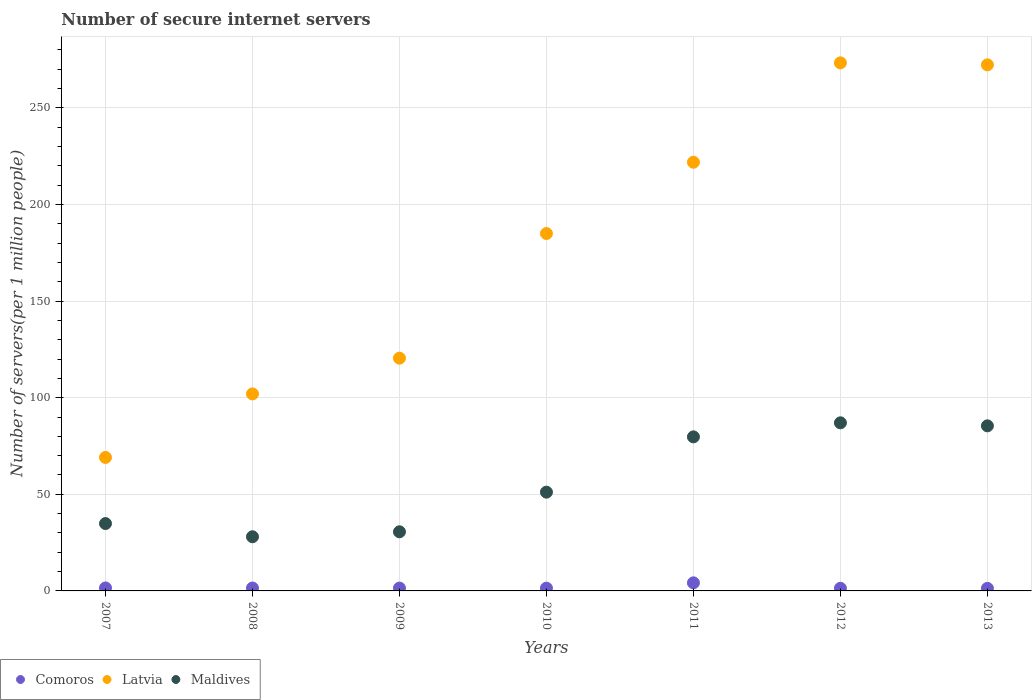What is the number of secure internet servers in Latvia in 2012?
Provide a short and direct response. 273.31. Across all years, what is the maximum number of secure internet servers in Comoros?
Your response must be concise. 4.19. Across all years, what is the minimum number of secure internet servers in Comoros?
Keep it short and to the point. 1.33. In which year was the number of secure internet servers in Latvia maximum?
Offer a terse response. 2012. In which year was the number of secure internet servers in Latvia minimum?
Your response must be concise. 2007. What is the total number of secure internet servers in Comoros in the graph?
Your response must be concise. 12.82. What is the difference between the number of secure internet servers in Maldives in 2007 and that in 2013?
Keep it short and to the point. -50.58. What is the difference between the number of secure internet servers in Comoros in 2011 and the number of secure internet servers in Maldives in 2007?
Make the answer very short. -30.67. What is the average number of secure internet servers in Comoros per year?
Ensure brevity in your answer.  1.83. In the year 2008, what is the difference between the number of secure internet servers in Latvia and number of secure internet servers in Comoros?
Provide a short and direct response. 100.46. In how many years, is the number of secure internet servers in Maldives greater than 270?
Your answer should be very brief. 0. What is the ratio of the number of secure internet servers in Latvia in 2007 to that in 2012?
Ensure brevity in your answer.  0.25. Is the number of secure internet servers in Maldives in 2009 less than that in 2012?
Offer a very short reply. Yes. What is the difference between the highest and the second highest number of secure internet servers in Comoros?
Offer a very short reply. 2.65. What is the difference between the highest and the lowest number of secure internet servers in Latvia?
Make the answer very short. 204.23. In how many years, is the number of secure internet servers in Comoros greater than the average number of secure internet servers in Comoros taken over all years?
Make the answer very short. 1. Is the number of secure internet servers in Maldives strictly greater than the number of secure internet servers in Latvia over the years?
Your answer should be compact. No. Is the number of secure internet servers in Comoros strictly less than the number of secure internet servers in Maldives over the years?
Offer a very short reply. Yes. How many dotlines are there?
Keep it short and to the point. 3. Are the values on the major ticks of Y-axis written in scientific E-notation?
Make the answer very short. No. Does the graph contain any zero values?
Provide a succinct answer. No. Does the graph contain grids?
Keep it short and to the point. Yes. Where does the legend appear in the graph?
Your answer should be very brief. Bottom left. How are the legend labels stacked?
Give a very brief answer. Horizontal. What is the title of the graph?
Your response must be concise. Number of secure internet servers. What is the label or title of the Y-axis?
Make the answer very short. Number of servers(per 1 million people). What is the Number of servers(per 1 million people) of Comoros in 2007?
Keep it short and to the point. 1.54. What is the Number of servers(per 1 million people) in Latvia in 2007?
Provide a short and direct response. 69.08. What is the Number of servers(per 1 million people) in Maldives in 2007?
Make the answer very short. 34.86. What is the Number of servers(per 1 million people) of Comoros in 2008?
Make the answer very short. 1.5. What is the Number of servers(per 1 million people) in Latvia in 2008?
Ensure brevity in your answer.  101.96. What is the Number of servers(per 1 million people) in Maldives in 2008?
Give a very brief answer. 28.04. What is the Number of servers(per 1 million people) of Comoros in 2009?
Ensure brevity in your answer.  1.47. What is the Number of servers(per 1 million people) of Latvia in 2009?
Provide a succinct answer. 120.47. What is the Number of servers(per 1 million people) of Maldives in 2009?
Keep it short and to the point. 30.61. What is the Number of servers(per 1 million people) in Comoros in 2010?
Keep it short and to the point. 1.43. What is the Number of servers(per 1 million people) of Latvia in 2010?
Offer a terse response. 184.98. What is the Number of servers(per 1 million people) of Maldives in 2010?
Provide a succinct answer. 51.12. What is the Number of servers(per 1 million people) in Comoros in 2011?
Provide a short and direct response. 4.19. What is the Number of servers(per 1 million people) in Latvia in 2011?
Ensure brevity in your answer.  221.88. What is the Number of servers(per 1 million people) in Maldives in 2011?
Keep it short and to the point. 79.74. What is the Number of servers(per 1 million people) of Comoros in 2012?
Make the answer very short. 1.36. What is the Number of servers(per 1 million people) in Latvia in 2012?
Offer a terse response. 273.31. What is the Number of servers(per 1 million people) in Maldives in 2012?
Provide a short and direct response. 87. What is the Number of servers(per 1 million people) of Comoros in 2013?
Your answer should be very brief. 1.33. What is the Number of servers(per 1 million people) of Latvia in 2013?
Your response must be concise. 272.28. What is the Number of servers(per 1 million people) in Maldives in 2013?
Provide a short and direct response. 85.44. Across all years, what is the maximum Number of servers(per 1 million people) in Comoros?
Provide a short and direct response. 4.19. Across all years, what is the maximum Number of servers(per 1 million people) of Latvia?
Provide a succinct answer. 273.31. Across all years, what is the maximum Number of servers(per 1 million people) in Maldives?
Provide a succinct answer. 87. Across all years, what is the minimum Number of servers(per 1 million people) in Comoros?
Keep it short and to the point. 1.33. Across all years, what is the minimum Number of servers(per 1 million people) of Latvia?
Provide a short and direct response. 69.08. Across all years, what is the minimum Number of servers(per 1 million people) of Maldives?
Your answer should be very brief. 28.04. What is the total Number of servers(per 1 million people) in Comoros in the graph?
Provide a succinct answer. 12.82. What is the total Number of servers(per 1 million people) of Latvia in the graph?
Ensure brevity in your answer.  1243.95. What is the total Number of servers(per 1 million people) in Maldives in the graph?
Make the answer very short. 396.8. What is the difference between the Number of servers(per 1 million people) in Comoros in 2007 and that in 2008?
Your answer should be very brief. 0.04. What is the difference between the Number of servers(per 1 million people) in Latvia in 2007 and that in 2008?
Provide a succinct answer. -32.88. What is the difference between the Number of servers(per 1 million people) of Maldives in 2007 and that in 2008?
Your response must be concise. 6.83. What is the difference between the Number of servers(per 1 million people) in Comoros in 2007 and that in 2009?
Offer a very short reply. 0.07. What is the difference between the Number of servers(per 1 million people) of Latvia in 2007 and that in 2009?
Provide a short and direct response. -51.39. What is the difference between the Number of servers(per 1 million people) of Maldives in 2007 and that in 2009?
Your response must be concise. 4.26. What is the difference between the Number of servers(per 1 million people) in Comoros in 2007 and that in 2010?
Offer a very short reply. 0.11. What is the difference between the Number of servers(per 1 million people) in Latvia in 2007 and that in 2010?
Ensure brevity in your answer.  -115.9. What is the difference between the Number of servers(per 1 million people) of Maldives in 2007 and that in 2010?
Provide a short and direct response. -16.25. What is the difference between the Number of servers(per 1 million people) in Comoros in 2007 and that in 2011?
Offer a very short reply. -2.65. What is the difference between the Number of servers(per 1 million people) in Latvia in 2007 and that in 2011?
Your answer should be very brief. -152.8. What is the difference between the Number of servers(per 1 million people) of Maldives in 2007 and that in 2011?
Provide a succinct answer. -44.87. What is the difference between the Number of servers(per 1 million people) of Comoros in 2007 and that in 2012?
Offer a very short reply. 0.18. What is the difference between the Number of servers(per 1 million people) of Latvia in 2007 and that in 2012?
Make the answer very short. -204.23. What is the difference between the Number of servers(per 1 million people) in Maldives in 2007 and that in 2012?
Keep it short and to the point. -52.14. What is the difference between the Number of servers(per 1 million people) in Comoros in 2007 and that in 2013?
Give a very brief answer. 0.21. What is the difference between the Number of servers(per 1 million people) of Latvia in 2007 and that in 2013?
Make the answer very short. -203.2. What is the difference between the Number of servers(per 1 million people) of Maldives in 2007 and that in 2013?
Give a very brief answer. -50.58. What is the difference between the Number of servers(per 1 million people) in Comoros in 2008 and that in 2009?
Provide a short and direct response. 0.04. What is the difference between the Number of servers(per 1 million people) of Latvia in 2008 and that in 2009?
Provide a succinct answer. -18.51. What is the difference between the Number of servers(per 1 million people) of Maldives in 2008 and that in 2009?
Your answer should be compact. -2.57. What is the difference between the Number of servers(per 1 million people) in Comoros in 2008 and that in 2010?
Your response must be concise. 0.07. What is the difference between the Number of servers(per 1 million people) of Latvia in 2008 and that in 2010?
Provide a succinct answer. -83.02. What is the difference between the Number of servers(per 1 million people) of Maldives in 2008 and that in 2010?
Provide a succinct answer. -23.08. What is the difference between the Number of servers(per 1 million people) in Comoros in 2008 and that in 2011?
Provide a short and direct response. -2.69. What is the difference between the Number of servers(per 1 million people) of Latvia in 2008 and that in 2011?
Offer a terse response. -119.92. What is the difference between the Number of servers(per 1 million people) of Maldives in 2008 and that in 2011?
Your answer should be compact. -51.7. What is the difference between the Number of servers(per 1 million people) of Comoros in 2008 and that in 2012?
Provide a succinct answer. 0.14. What is the difference between the Number of servers(per 1 million people) of Latvia in 2008 and that in 2012?
Offer a terse response. -171.35. What is the difference between the Number of servers(per 1 million people) of Maldives in 2008 and that in 2012?
Your answer should be very brief. -58.97. What is the difference between the Number of servers(per 1 million people) in Comoros in 2008 and that in 2013?
Keep it short and to the point. 0.17. What is the difference between the Number of servers(per 1 million people) of Latvia in 2008 and that in 2013?
Keep it short and to the point. -170.32. What is the difference between the Number of servers(per 1 million people) in Maldives in 2008 and that in 2013?
Give a very brief answer. -57.41. What is the difference between the Number of servers(per 1 million people) of Comoros in 2009 and that in 2010?
Your response must be concise. 0.04. What is the difference between the Number of servers(per 1 million people) of Latvia in 2009 and that in 2010?
Your answer should be very brief. -64.51. What is the difference between the Number of servers(per 1 million people) in Maldives in 2009 and that in 2010?
Offer a very short reply. -20.51. What is the difference between the Number of servers(per 1 million people) of Comoros in 2009 and that in 2011?
Keep it short and to the point. -2.72. What is the difference between the Number of servers(per 1 million people) in Latvia in 2009 and that in 2011?
Offer a very short reply. -101.41. What is the difference between the Number of servers(per 1 million people) in Maldives in 2009 and that in 2011?
Offer a very short reply. -49.13. What is the difference between the Number of servers(per 1 million people) of Comoros in 2009 and that in 2012?
Offer a very short reply. 0.1. What is the difference between the Number of servers(per 1 million people) of Latvia in 2009 and that in 2012?
Make the answer very short. -152.84. What is the difference between the Number of servers(per 1 million people) in Maldives in 2009 and that in 2012?
Ensure brevity in your answer.  -56.39. What is the difference between the Number of servers(per 1 million people) of Comoros in 2009 and that in 2013?
Your answer should be very brief. 0.14. What is the difference between the Number of servers(per 1 million people) of Latvia in 2009 and that in 2013?
Give a very brief answer. -151.81. What is the difference between the Number of servers(per 1 million people) of Maldives in 2009 and that in 2013?
Ensure brevity in your answer.  -54.84. What is the difference between the Number of servers(per 1 million people) of Comoros in 2010 and that in 2011?
Offer a terse response. -2.76. What is the difference between the Number of servers(per 1 million people) in Latvia in 2010 and that in 2011?
Give a very brief answer. -36.9. What is the difference between the Number of servers(per 1 million people) in Maldives in 2010 and that in 2011?
Your answer should be very brief. -28.62. What is the difference between the Number of servers(per 1 million people) of Comoros in 2010 and that in 2012?
Make the answer very short. 0.07. What is the difference between the Number of servers(per 1 million people) of Latvia in 2010 and that in 2012?
Offer a terse response. -88.33. What is the difference between the Number of servers(per 1 million people) of Maldives in 2010 and that in 2012?
Keep it short and to the point. -35.89. What is the difference between the Number of servers(per 1 million people) of Comoros in 2010 and that in 2013?
Make the answer very short. 0.1. What is the difference between the Number of servers(per 1 million people) in Latvia in 2010 and that in 2013?
Your answer should be compact. -87.3. What is the difference between the Number of servers(per 1 million people) of Maldives in 2010 and that in 2013?
Offer a terse response. -34.33. What is the difference between the Number of servers(per 1 million people) of Comoros in 2011 and that in 2012?
Offer a very short reply. 2.83. What is the difference between the Number of servers(per 1 million people) in Latvia in 2011 and that in 2012?
Offer a very short reply. -51.43. What is the difference between the Number of servers(per 1 million people) of Maldives in 2011 and that in 2012?
Provide a succinct answer. -7.27. What is the difference between the Number of servers(per 1 million people) of Comoros in 2011 and that in 2013?
Keep it short and to the point. 2.86. What is the difference between the Number of servers(per 1 million people) of Latvia in 2011 and that in 2013?
Give a very brief answer. -50.4. What is the difference between the Number of servers(per 1 million people) in Maldives in 2011 and that in 2013?
Make the answer very short. -5.71. What is the difference between the Number of servers(per 1 million people) of Comoros in 2012 and that in 2013?
Offer a terse response. 0.03. What is the difference between the Number of servers(per 1 million people) in Latvia in 2012 and that in 2013?
Provide a succinct answer. 1.03. What is the difference between the Number of servers(per 1 million people) in Maldives in 2012 and that in 2013?
Provide a succinct answer. 1.56. What is the difference between the Number of servers(per 1 million people) in Comoros in 2007 and the Number of servers(per 1 million people) in Latvia in 2008?
Make the answer very short. -100.42. What is the difference between the Number of servers(per 1 million people) in Comoros in 2007 and the Number of servers(per 1 million people) in Maldives in 2008?
Your response must be concise. -26.5. What is the difference between the Number of servers(per 1 million people) of Latvia in 2007 and the Number of servers(per 1 million people) of Maldives in 2008?
Offer a terse response. 41.05. What is the difference between the Number of servers(per 1 million people) of Comoros in 2007 and the Number of servers(per 1 million people) of Latvia in 2009?
Offer a very short reply. -118.93. What is the difference between the Number of servers(per 1 million people) in Comoros in 2007 and the Number of servers(per 1 million people) in Maldives in 2009?
Your answer should be very brief. -29.07. What is the difference between the Number of servers(per 1 million people) in Latvia in 2007 and the Number of servers(per 1 million people) in Maldives in 2009?
Provide a succinct answer. 38.47. What is the difference between the Number of servers(per 1 million people) in Comoros in 2007 and the Number of servers(per 1 million people) in Latvia in 2010?
Your answer should be compact. -183.44. What is the difference between the Number of servers(per 1 million people) of Comoros in 2007 and the Number of servers(per 1 million people) of Maldives in 2010?
Your answer should be very brief. -49.58. What is the difference between the Number of servers(per 1 million people) in Latvia in 2007 and the Number of servers(per 1 million people) in Maldives in 2010?
Provide a short and direct response. 17.96. What is the difference between the Number of servers(per 1 million people) of Comoros in 2007 and the Number of servers(per 1 million people) of Latvia in 2011?
Your answer should be very brief. -220.34. What is the difference between the Number of servers(per 1 million people) of Comoros in 2007 and the Number of servers(per 1 million people) of Maldives in 2011?
Offer a terse response. -78.2. What is the difference between the Number of servers(per 1 million people) in Latvia in 2007 and the Number of servers(per 1 million people) in Maldives in 2011?
Your response must be concise. -10.66. What is the difference between the Number of servers(per 1 million people) of Comoros in 2007 and the Number of servers(per 1 million people) of Latvia in 2012?
Provide a short and direct response. -271.77. What is the difference between the Number of servers(per 1 million people) in Comoros in 2007 and the Number of servers(per 1 million people) in Maldives in 2012?
Keep it short and to the point. -85.46. What is the difference between the Number of servers(per 1 million people) of Latvia in 2007 and the Number of servers(per 1 million people) of Maldives in 2012?
Your answer should be compact. -17.92. What is the difference between the Number of servers(per 1 million people) in Comoros in 2007 and the Number of servers(per 1 million people) in Latvia in 2013?
Offer a very short reply. -270.74. What is the difference between the Number of servers(per 1 million people) of Comoros in 2007 and the Number of servers(per 1 million people) of Maldives in 2013?
Your response must be concise. -83.9. What is the difference between the Number of servers(per 1 million people) of Latvia in 2007 and the Number of servers(per 1 million people) of Maldives in 2013?
Give a very brief answer. -16.36. What is the difference between the Number of servers(per 1 million people) of Comoros in 2008 and the Number of servers(per 1 million people) of Latvia in 2009?
Provide a succinct answer. -118.96. What is the difference between the Number of servers(per 1 million people) of Comoros in 2008 and the Number of servers(per 1 million people) of Maldives in 2009?
Your response must be concise. -29.11. What is the difference between the Number of servers(per 1 million people) of Latvia in 2008 and the Number of servers(per 1 million people) of Maldives in 2009?
Provide a short and direct response. 71.35. What is the difference between the Number of servers(per 1 million people) of Comoros in 2008 and the Number of servers(per 1 million people) of Latvia in 2010?
Give a very brief answer. -183.47. What is the difference between the Number of servers(per 1 million people) in Comoros in 2008 and the Number of servers(per 1 million people) in Maldives in 2010?
Keep it short and to the point. -49.61. What is the difference between the Number of servers(per 1 million people) of Latvia in 2008 and the Number of servers(per 1 million people) of Maldives in 2010?
Make the answer very short. 50.84. What is the difference between the Number of servers(per 1 million people) in Comoros in 2008 and the Number of servers(per 1 million people) in Latvia in 2011?
Provide a succinct answer. -220.37. What is the difference between the Number of servers(per 1 million people) in Comoros in 2008 and the Number of servers(per 1 million people) in Maldives in 2011?
Your answer should be compact. -78.23. What is the difference between the Number of servers(per 1 million people) of Latvia in 2008 and the Number of servers(per 1 million people) of Maldives in 2011?
Your answer should be very brief. 22.22. What is the difference between the Number of servers(per 1 million people) in Comoros in 2008 and the Number of servers(per 1 million people) in Latvia in 2012?
Give a very brief answer. -271.81. What is the difference between the Number of servers(per 1 million people) of Comoros in 2008 and the Number of servers(per 1 million people) of Maldives in 2012?
Your answer should be compact. -85.5. What is the difference between the Number of servers(per 1 million people) in Latvia in 2008 and the Number of servers(per 1 million people) in Maldives in 2012?
Make the answer very short. 14.96. What is the difference between the Number of servers(per 1 million people) in Comoros in 2008 and the Number of servers(per 1 million people) in Latvia in 2013?
Provide a short and direct response. -270.78. What is the difference between the Number of servers(per 1 million people) in Comoros in 2008 and the Number of servers(per 1 million people) in Maldives in 2013?
Keep it short and to the point. -83.94. What is the difference between the Number of servers(per 1 million people) of Latvia in 2008 and the Number of servers(per 1 million people) of Maldives in 2013?
Give a very brief answer. 16.52. What is the difference between the Number of servers(per 1 million people) of Comoros in 2009 and the Number of servers(per 1 million people) of Latvia in 2010?
Offer a terse response. -183.51. What is the difference between the Number of servers(per 1 million people) in Comoros in 2009 and the Number of servers(per 1 million people) in Maldives in 2010?
Your answer should be compact. -49.65. What is the difference between the Number of servers(per 1 million people) in Latvia in 2009 and the Number of servers(per 1 million people) in Maldives in 2010?
Offer a very short reply. 69.35. What is the difference between the Number of servers(per 1 million people) in Comoros in 2009 and the Number of servers(per 1 million people) in Latvia in 2011?
Offer a very short reply. -220.41. What is the difference between the Number of servers(per 1 million people) of Comoros in 2009 and the Number of servers(per 1 million people) of Maldives in 2011?
Provide a succinct answer. -78.27. What is the difference between the Number of servers(per 1 million people) in Latvia in 2009 and the Number of servers(per 1 million people) in Maldives in 2011?
Ensure brevity in your answer.  40.73. What is the difference between the Number of servers(per 1 million people) in Comoros in 2009 and the Number of servers(per 1 million people) in Latvia in 2012?
Your answer should be compact. -271.84. What is the difference between the Number of servers(per 1 million people) of Comoros in 2009 and the Number of servers(per 1 million people) of Maldives in 2012?
Keep it short and to the point. -85.54. What is the difference between the Number of servers(per 1 million people) in Latvia in 2009 and the Number of servers(per 1 million people) in Maldives in 2012?
Offer a terse response. 33.46. What is the difference between the Number of servers(per 1 million people) of Comoros in 2009 and the Number of servers(per 1 million people) of Latvia in 2013?
Offer a very short reply. -270.81. What is the difference between the Number of servers(per 1 million people) of Comoros in 2009 and the Number of servers(per 1 million people) of Maldives in 2013?
Your answer should be very brief. -83.98. What is the difference between the Number of servers(per 1 million people) of Latvia in 2009 and the Number of servers(per 1 million people) of Maldives in 2013?
Your response must be concise. 35.02. What is the difference between the Number of servers(per 1 million people) in Comoros in 2010 and the Number of servers(per 1 million people) in Latvia in 2011?
Offer a terse response. -220.44. What is the difference between the Number of servers(per 1 million people) in Comoros in 2010 and the Number of servers(per 1 million people) in Maldives in 2011?
Keep it short and to the point. -78.3. What is the difference between the Number of servers(per 1 million people) in Latvia in 2010 and the Number of servers(per 1 million people) in Maldives in 2011?
Make the answer very short. 105.24. What is the difference between the Number of servers(per 1 million people) in Comoros in 2010 and the Number of servers(per 1 million people) in Latvia in 2012?
Offer a terse response. -271.88. What is the difference between the Number of servers(per 1 million people) of Comoros in 2010 and the Number of servers(per 1 million people) of Maldives in 2012?
Offer a very short reply. -85.57. What is the difference between the Number of servers(per 1 million people) in Latvia in 2010 and the Number of servers(per 1 million people) in Maldives in 2012?
Make the answer very short. 97.97. What is the difference between the Number of servers(per 1 million people) of Comoros in 2010 and the Number of servers(per 1 million people) of Latvia in 2013?
Your answer should be very brief. -270.85. What is the difference between the Number of servers(per 1 million people) in Comoros in 2010 and the Number of servers(per 1 million people) in Maldives in 2013?
Your answer should be compact. -84.01. What is the difference between the Number of servers(per 1 million people) of Latvia in 2010 and the Number of servers(per 1 million people) of Maldives in 2013?
Your answer should be compact. 99.53. What is the difference between the Number of servers(per 1 million people) of Comoros in 2011 and the Number of servers(per 1 million people) of Latvia in 2012?
Your answer should be very brief. -269.12. What is the difference between the Number of servers(per 1 million people) in Comoros in 2011 and the Number of servers(per 1 million people) in Maldives in 2012?
Your answer should be very brief. -82.81. What is the difference between the Number of servers(per 1 million people) of Latvia in 2011 and the Number of servers(per 1 million people) of Maldives in 2012?
Ensure brevity in your answer.  134.87. What is the difference between the Number of servers(per 1 million people) of Comoros in 2011 and the Number of servers(per 1 million people) of Latvia in 2013?
Your response must be concise. -268.09. What is the difference between the Number of servers(per 1 million people) of Comoros in 2011 and the Number of servers(per 1 million people) of Maldives in 2013?
Make the answer very short. -81.25. What is the difference between the Number of servers(per 1 million people) of Latvia in 2011 and the Number of servers(per 1 million people) of Maldives in 2013?
Make the answer very short. 136.43. What is the difference between the Number of servers(per 1 million people) of Comoros in 2012 and the Number of servers(per 1 million people) of Latvia in 2013?
Give a very brief answer. -270.92. What is the difference between the Number of servers(per 1 million people) of Comoros in 2012 and the Number of servers(per 1 million people) of Maldives in 2013?
Make the answer very short. -84.08. What is the difference between the Number of servers(per 1 million people) in Latvia in 2012 and the Number of servers(per 1 million people) in Maldives in 2013?
Provide a short and direct response. 187.87. What is the average Number of servers(per 1 million people) of Comoros per year?
Make the answer very short. 1.83. What is the average Number of servers(per 1 million people) in Latvia per year?
Give a very brief answer. 177.71. What is the average Number of servers(per 1 million people) in Maldives per year?
Ensure brevity in your answer.  56.69. In the year 2007, what is the difference between the Number of servers(per 1 million people) in Comoros and Number of servers(per 1 million people) in Latvia?
Provide a succinct answer. -67.54. In the year 2007, what is the difference between the Number of servers(per 1 million people) of Comoros and Number of servers(per 1 million people) of Maldives?
Offer a very short reply. -33.32. In the year 2007, what is the difference between the Number of servers(per 1 million people) of Latvia and Number of servers(per 1 million people) of Maldives?
Your answer should be very brief. 34.22. In the year 2008, what is the difference between the Number of servers(per 1 million people) in Comoros and Number of servers(per 1 million people) in Latvia?
Provide a succinct answer. -100.46. In the year 2008, what is the difference between the Number of servers(per 1 million people) of Comoros and Number of servers(per 1 million people) of Maldives?
Ensure brevity in your answer.  -26.53. In the year 2008, what is the difference between the Number of servers(per 1 million people) in Latvia and Number of servers(per 1 million people) in Maldives?
Give a very brief answer. 73.92. In the year 2009, what is the difference between the Number of servers(per 1 million people) in Comoros and Number of servers(per 1 million people) in Latvia?
Your response must be concise. -119. In the year 2009, what is the difference between the Number of servers(per 1 million people) of Comoros and Number of servers(per 1 million people) of Maldives?
Give a very brief answer. -29.14. In the year 2009, what is the difference between the Number of servers(per 1 million people) of Latvia and Number of servers(per 1 million people) of Maldives?
Provide a short and direct response. 89.86. In the year 2010, what is the difference between the Number of servers(per 1 million people) of Comoros and Number of servers(per 1 million people) of Latvia?
Make the answer very short. -183.55. In the year 2010, what is the difference between the Number of servers(per 1 million people) in Comoros and Number of servers(per 1 million people) in Maldives?
Give a very brief answer. -49.69. In the year 2010, what is the difference between the Number of servers(per 1 million people) in Latvia and Number of servers(per 1 million people) in Maldives?
Make the answer very short. 133.86. In the year 2011, what is the difference between the Number of servers(per 1 million people) of Comoros and Number of servers(per 1 million people) of Latvia?
Your answer should be very brief. -217.69. In the year 2011, what is the difference between the Number of servers(per 1 million people) of Comoros and Number of servers(per 1 million people) of Maldives?
Provide a succinct answer. -75.55. In the year 2011, what is the difference between the Number of servers(per 1 million people) of Latvia and Number of servers(per 1 million people) of Maldives?
Your response must be concise. 142.14. In the year 2012, what is the difference between the Number of servers(per 1 million people) of Comoros and Number of servers(per 1 million people) of Latvia?
Keep it short and to the point. -271.95. In the year 2012, what is the difference between the Number of servers(per 1 million people) in Comoros and Number of servers(per 1 million people) in Maldives?
Provide a succinct answer. -85.64. In the year 2012, what is the difference between the Number of servers(per 1 million people) in Latvia and Number of servers(per 1 million people) in Maldives?
Keep it short and to the point. 186.31. In the year 2013, what is the difference between the Number of servers(per 1 million people) of Comoros and Number of servers(per 1 million people) of Latvia?
Your response must be concise. -270.95. In the year 2013, what is the difference between the Number of servers(per 1 million people) in Comoros and Number of servers(per 1 million people) in Maldives?
Your answer should be very brief. -84.11. In the year 2013, what is the difference between the Number of servers(per 1 million people) in Latvia and Number of servers(per 1 million people) in Maldives?
Offer a terse response. 186.84. What is the ratio of the Number of servers(per 1 million people) in Comoros in 2007 to that in 2008?
Offer a very short reply. 1.02. What is the ratio of the Number of servers(per 1 million people) in Latvia in 2007 to that in 2008?
Give a very brief answer. 0.68. What is the ratio of the Number of servers(per 1 million people) of Maldives in 2007 to that in 2008?
Keep it short and to the point. 1.24. What is the ratio of the Number of servers(per 1 million people) in Comoros in 2007 to that in 2009?
Provide a succinct answer. 1.05. What is the ratio of the Number of servers(per 1 million people) in Latvia in 2007 to that in 2009?
Your answer should be very brief. 0.57. What is the ratio of the Number of servers(per 1 million people) of Maldives in 2007 to that in 2009?
Provide a short and direct response. 1.14. What is the ratio of the Number of servers(per 1 million people) of Comoros in 2007 to that in 2010?
Your answer should be very brief. 1.08. What is the ratio of the Number of servers(per 1 million people) of Latvia in 2007 to that in 2010?
Make the answer very short. 0.37. What is the ratio of the Number of servers(per 1 million people) in Maldives in 2007 to that in 2010?
Provide a short and direct response. 0.68. What is the ratio of the Number of servers(per 1 million people) in Comoros in 2007 to that in 2011?
Provide a short and direct response. 0.37. What is the ratio of the Number of servers(per 1 million people) in Latvia in 2007 to that in 2011?
Provide a short and direct response. 0.31. What is the ratio of the Number of servers(per 1 million people) of Maldives in 2007 to that in 2011?
Offer a terse response. 0.44. What is the ratio of the Number of servers(per 1 million people) in Comoros in 2007 to that in 2012?
Keep it short and to the point. 1.13. What is the ratio of the Number of servers(per 1 million people) of Latvia in 2007 to that in 2012?
Your answer should be very brief. 0.25. What is the ratio of the Number of servers(per 1 million people) in Maldives in 2007 to that in 2012?
Your answer should be compact. 0.4. What is the ratio of the Number of servers(per 1 million people) of Comoros in 2007 to that in 2013?
Your answer should be compact. 1.16. What is the ratio of the Number of servers(per 1 million people) of Latvia in 2007 to that in 2013?
Offer a terse response. 0.25. What is the ratio of the Number of servers(per 1 million people) in Maldives in 2007 to that in 2013?
Give a very brief answer. 0.41. What is the ratio of the Number of servers(per 1 million people) of Comoros in 2008 to that in 2009?
Provide a short and direct response. 1.02. What is the ratio of the Number of servers(per 1 million people) of Latvia in 2008 to that in 2009?
Keep it short and to the point. 0.85. What is the ratio of the Number of servers(per 1 million people) in Maldives in 2008 to that in 2009?
Your answer should be compact. 0.92. What is the ratio of the Number of servers(per 1 million people) of Comoros in 2008 to that in 2010?
Provide a short and direct response. 1.05. What is the ratio of the Number of servers(per 1 million people) of Latvia in 2008 to that in 2010?
Provide a succinct answer. 0.55. What is the ratio of the Number of servers(per 1 million people) in Maldives in 2008 to that in 2010?
Provide a short and direct response. 0.55. What is the ratio of the Number of servers(per 1 million people) of Comoros in 2008 to that in 2011?
Ensure brevity in your answer.  0.36. What is the ratio of the Number of servers(per 1 million people) of Latvia in 2008 to that in 2011?
Keep it short and to the point. 0.46. What is the ratio of the Number of servers(per 1 million people) of Maldives in 2008 to that in 2011?
Offer a terse response. 0.35. What is the ratio of the Number of servers(per 1 million people) in Comoros in 2008 to that in 2012?
Offer a terse response. 1.1. What is the ratio of the Number of servers(per 1 million people) of Latvia in 2008 to that in 2012?
Your response must be concise. 0.37. What is the ratio of the Number of servers(per 1 million people) of Maldives in 2008 to that in 2012?
Make the answer very short. 0.32. What is the ratio of the Number of servers(per 1 million people) of Comoros in 2008 to that in 2013?
Provide a short and direct response. 1.13. What is the ratio of the Number of servers(per 1 million people) in Latvia in 2008 to that in 2013?
Provide a succinct answer. 0.37. What is the ratio of the Number of servers(per 1 million people) in Maldives in 2008 to that in 2013?
Your answer should be very brief. 0.33. What is the ratio of the Number of servers(per 1 million people) of Comoros in 2009 to that in 2010?
Offer a very short reply. 1.02. What is the ratio of the Number of servers(per 1 million people) of Latvia in 2009 to that in 2010?
Offer a very short reply. 0.65. What is the ratio of the Number of servers(per 1 million people) in Maldives in 2009 to that in 2010?
Give a very brief answer. 0.6. What is the ratio of the Number of servers(per 1 million people) of Comoros in 2009 to that in 2011?
Your answer should be very brief. 0.35. What is the ratio of the Number of servers(per 1 million people) in Latvia in 2009 to that in 2011?
Your answer should be very brief. 0.54. What is the ratio of the Number of servers(per 1 million people) of Maldives in 2009 to that in 2011?
Keep it short and to the point. 0.38. What is the ratio of the Number of servers(per 1 million people) in Comoros in 2009 to that in 2012?
Provide a succinct answer. 1.08. What is the ratio of the Number of servers(per 1 million people) in Latvia in 2009 to that in 2012?
Offer a terse response. 0.44. What is the ratio of the Number of servers(per 1 million people) of Maldives in 2009 to that in 2012?
Ensure brevity in your answer.  0.35. What is the ratio of the Number of servers(per 1 million people) in Comoros in 2009 to that in 2013?
Provide a succinct answer. 1.1. What is the ratio of the Number of servers(per 1 million people) of Latvia in 2009 to that in 2013?
Your answer should be compact. 0.44. What is the ratio of the Number of servers(per 1 million people) in Maldives in 2009 to that in 2013?
Offer a terse response. 0.36. What is the ratio of the Number of servers(per 1 million people) of Comoros in 2010 to that in 2011?
Make the answer very short. 0.34. What is the ratio of the Number of servers(per 1 million people) of Latvia in 2010 to that in 2011?
Offer a terse response. 0.83. What is the ratio of the Number of servers(per 1 million people) in Maldives in 2010 to that in 2011?
Make the answer very short. 0.64. What is the ratio of the Number of servers(per 1 million people) in Comoros in 2010 to that in 2012?
Your answer should be compact. 1.05. What is the ratio of the Number of servers(per 1 million people) of Latvia in 2010 to that in 2012?
Your answer should be compact. 0.68. What is the ratio of the Number of servers(per 1 million people) of Maldives in 2010 to that in 2012?
Give a very brief answer. 0.59. What is the ratio of the Number of servers(per 1 million people) of Comoros in 2010 to that in 2013?
Offer a terse response. 1.08. What is the ratio of the Number of servers(per 1 million people) in Latvia in 2010 to that in 2013?
Ensure brevity in your answer.  0.68. What is the ratio of the Number of servers(per 1 million people) of Maldives in 2010 to that in 2013?
Ensure brevity in your answer.  0.6. What is the ratio of the Number of servers(per 1 million people) of Comoros in 2011 to that in 2012?
Offer a terse response. 3.07. What is the ratio of the Number of servers(per 1 million people) of Latvia in 2011 to that in 2012?
Ensure brevity in your answer.  0.81. What is the ratio of the Number of servers(per 1 million people) of Maldives in 2011 to that in 2012?
Offer a terse response. 0.92. What is the ratio of the Number of servers(per 1 million people) of Comoros in 2011 to that in 2013?
Provide a succinct answer. 3.15. What is the ratio of the Number of servers(per 1 million people) of Latvia in 2011 to that in 2013?
Keep it short and to the point. 0.81. What is the ratio of the Number of servers(per 1 million people) of Maldives in 2011 to that in 2013?
Provide a short and direct response. 0.93. What is the ratio of the Number of servers(per 1 million people) of Comoros in 2012 to that in 2013?
Offer a very short reply. 1.02. What is the ratio of the Number of servers(per 1 million people) in Maldives in 2012 to that in 2013?
Provide a short and direct response. 1.02. What is the difference between the highest and the second highest Number of servers(per 1 million people) of Comoros?
Keep it short and to the point. 2.65. What is the difference between the highest and the second highest Number of servers(per 1 million people) in Latvia?
Ensure brevity in your answer.  1.03. What is the difference between the highest and the second highest Number of servers(per 1 million people) in Maldives?
Your answer should be very brief. 1.56. What is the difference between the highest and the lowest Number of servers(per 1 million people) of Comoros?
Your response must be concise. 2.86. What is the difference between the highest and the lowest Number of servers(per 1 million people) of Latvia?
Provide a short and direct response. 204.23. What is the difference between the highest and the lowest Number of servers(per 1 million people) in Maldives?
Your answer should be very brief. 58.97. 